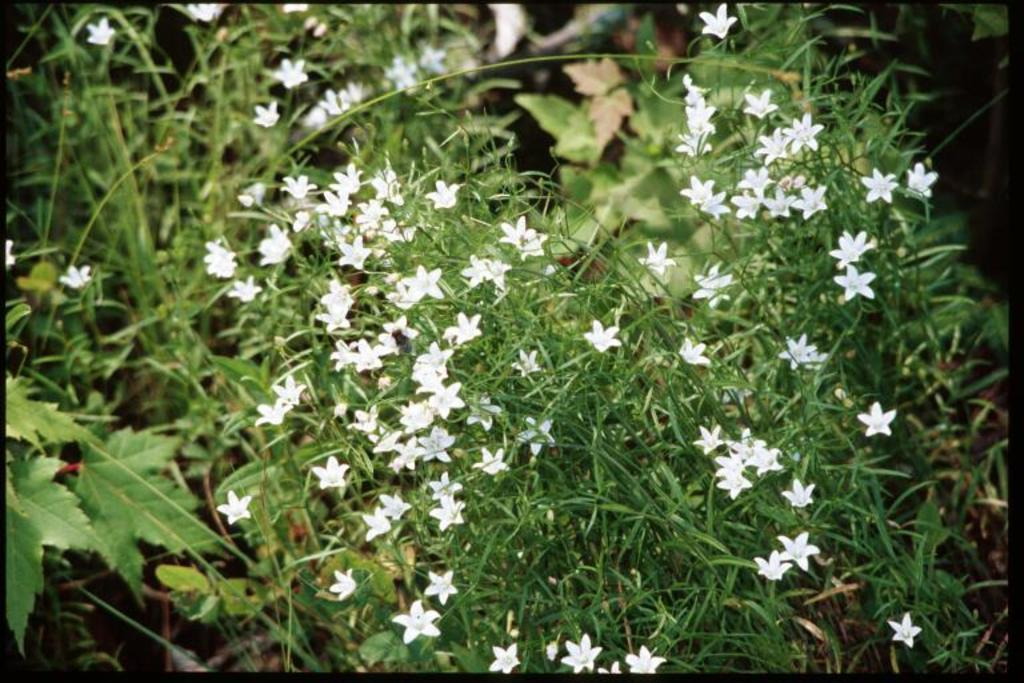What types of vegetation can be seen in the foreground of the image? There are plants and flowers in the foreground of the image. Can you describe the vegetation in more detail? The plants and flowers in the foreground include leaves and petals. What can be seen in the background of the image? There are leaves visible in the background of the image. What type of unit can be seen measuring the height of the flowers in the image? There is no unit present in the image, and the flowers' height is not being measured. 